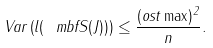Convert formula to latex. <formula><loc_0><loc_0><loc_500><loc_500>V a r \left ( l ( \ m b f { S } ( J ) ) \right ) \leq \frac { ( o s t \max ) ^ { 2 } } { n } .</formula> 